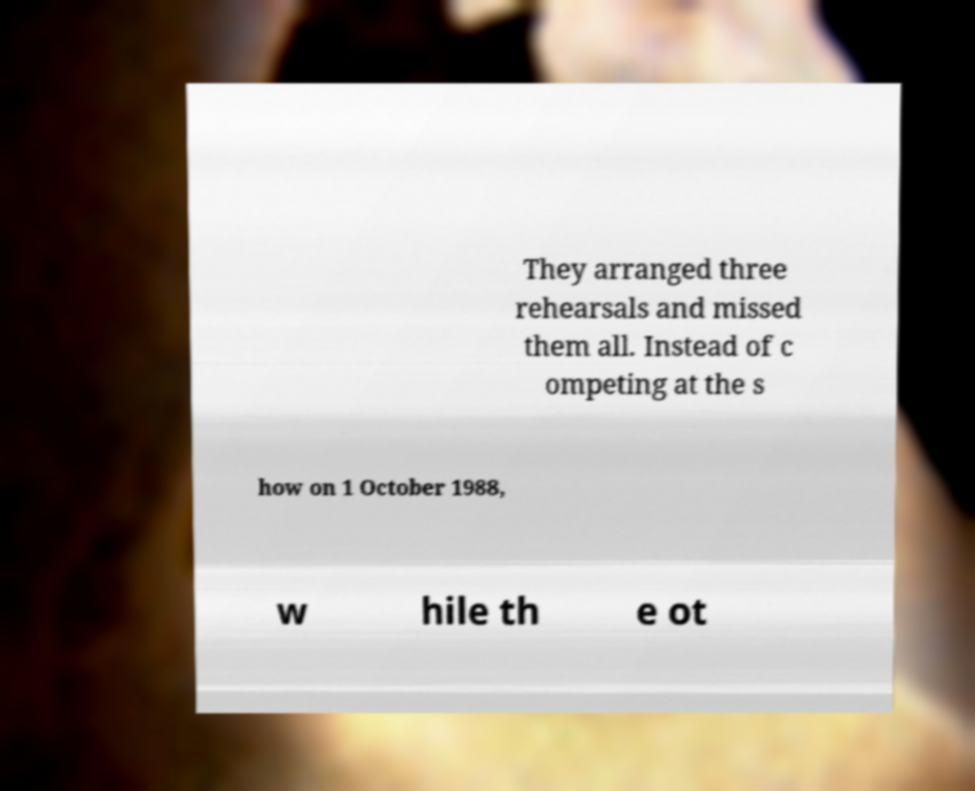There's text embedded in this image that I need extracted. Can you transcribe it verbatim? They arranged three rehearsals and missed them all. Instead of c ompeting at the s how on 1 October 1988, w hile th e ot 